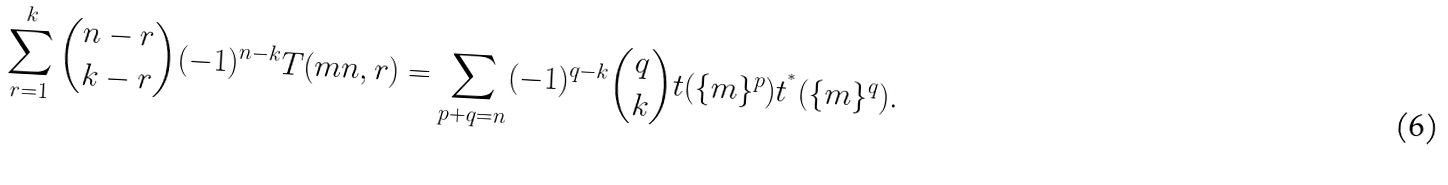<formula> <loc_0><loc_0><loc_500><loc_500>\sum _ { r = 1 } ^ { k } \binom { n - r } { k - r } ( - 1 ) ^ { n - k } T ( m n , r ) = \sum _ { p + q = n } ( - 1 ) ^ { q - k } \binom { q } { k } t ( \{ m \} ^ { p } ) t ^ { ^ { * } } ( \{ m \} ^ { q } ) .</formula> 